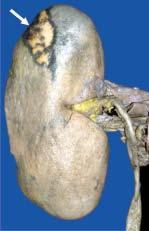where is the wedge-shaped infarct slightly depressed?
Answer the question using a single word or phrase. On the surface 